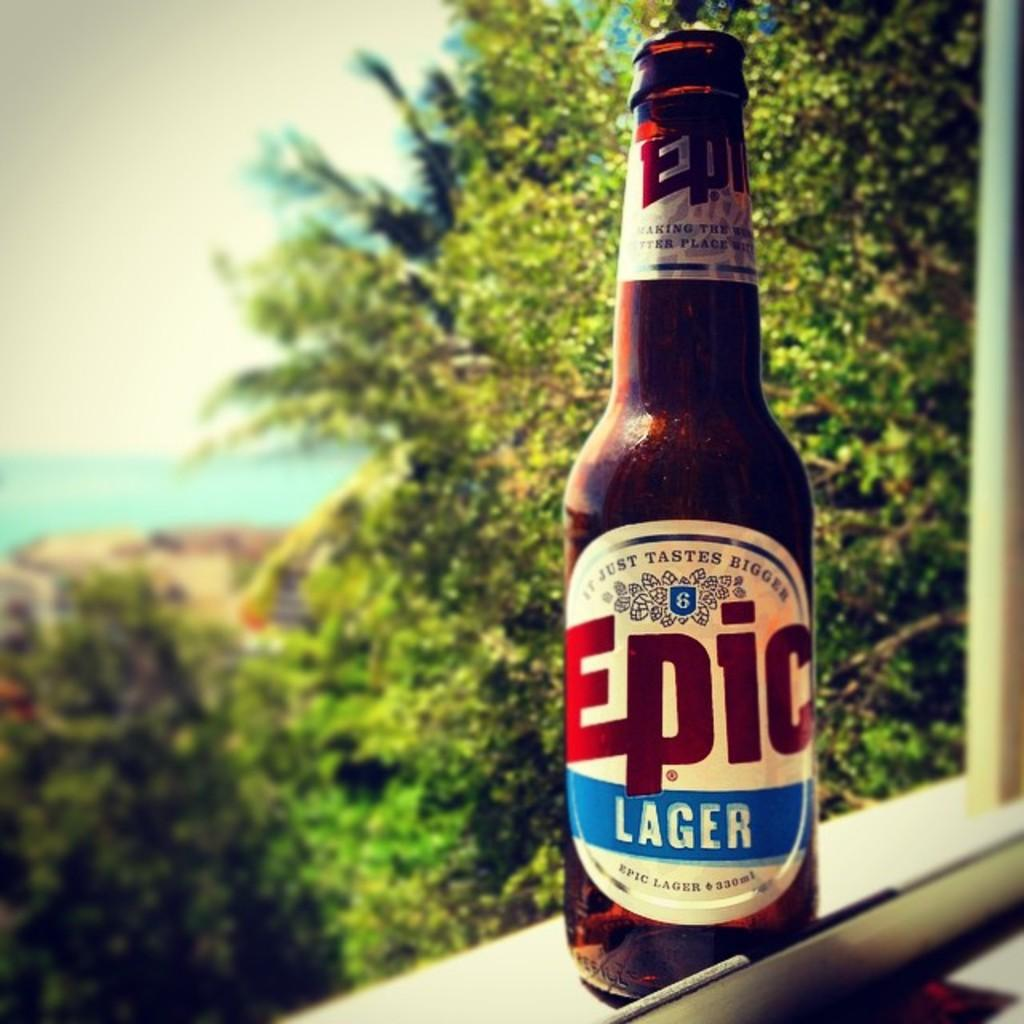<image>
Present a compact description of the photo's key features. A bottle of Epic Lager sits on a windowsill on a beautiful day. 